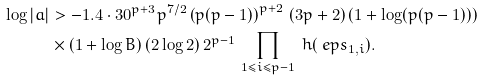Convert formula to latex. <formula><loc_0><loc_0><loc_500><loc_500>\log | \L a | & > - 1 . 4 \cdot 3 0 ^ { p + 3 } p ^ { 7 / 2 } \left ( p ( p - 1 ) \right ) ^ { p + 2 } \, ( 3 p + 2 ) \left ( 1 + \log ( p ( p - 1 ) ) \right ) \\ & \times ( 1 + \log B ) \, ( 2 \log 2 ) \, 2 ^ { p - 1 } \, \prod _ { 1 \leq i \leq p - 1 } \ h ( \ e p s _ { 1 , i } ) .</formula> 